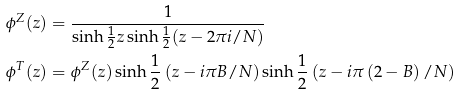Convert formula to latex. <formula><loc_0><loc_0><loc_500><loc_500>\phi ^ { Z } ( z ) & = \frac { 1 } { \sinh \frac { 1 } { 2 } z \sinh \frac { 1 } { 2 } ( z - 2 \pi i / N ) } \\ \phi ^ { T } ( z ) & = \phi ^ { Z } ( z ) \sinh \frac { 1 } { 2 } \left ( z - i \pi B / N \right ) \sinh \frac { 1 } { 2 } \left ( z - i \pi \left ( 2 - B \right ) / N \right )</formula> 